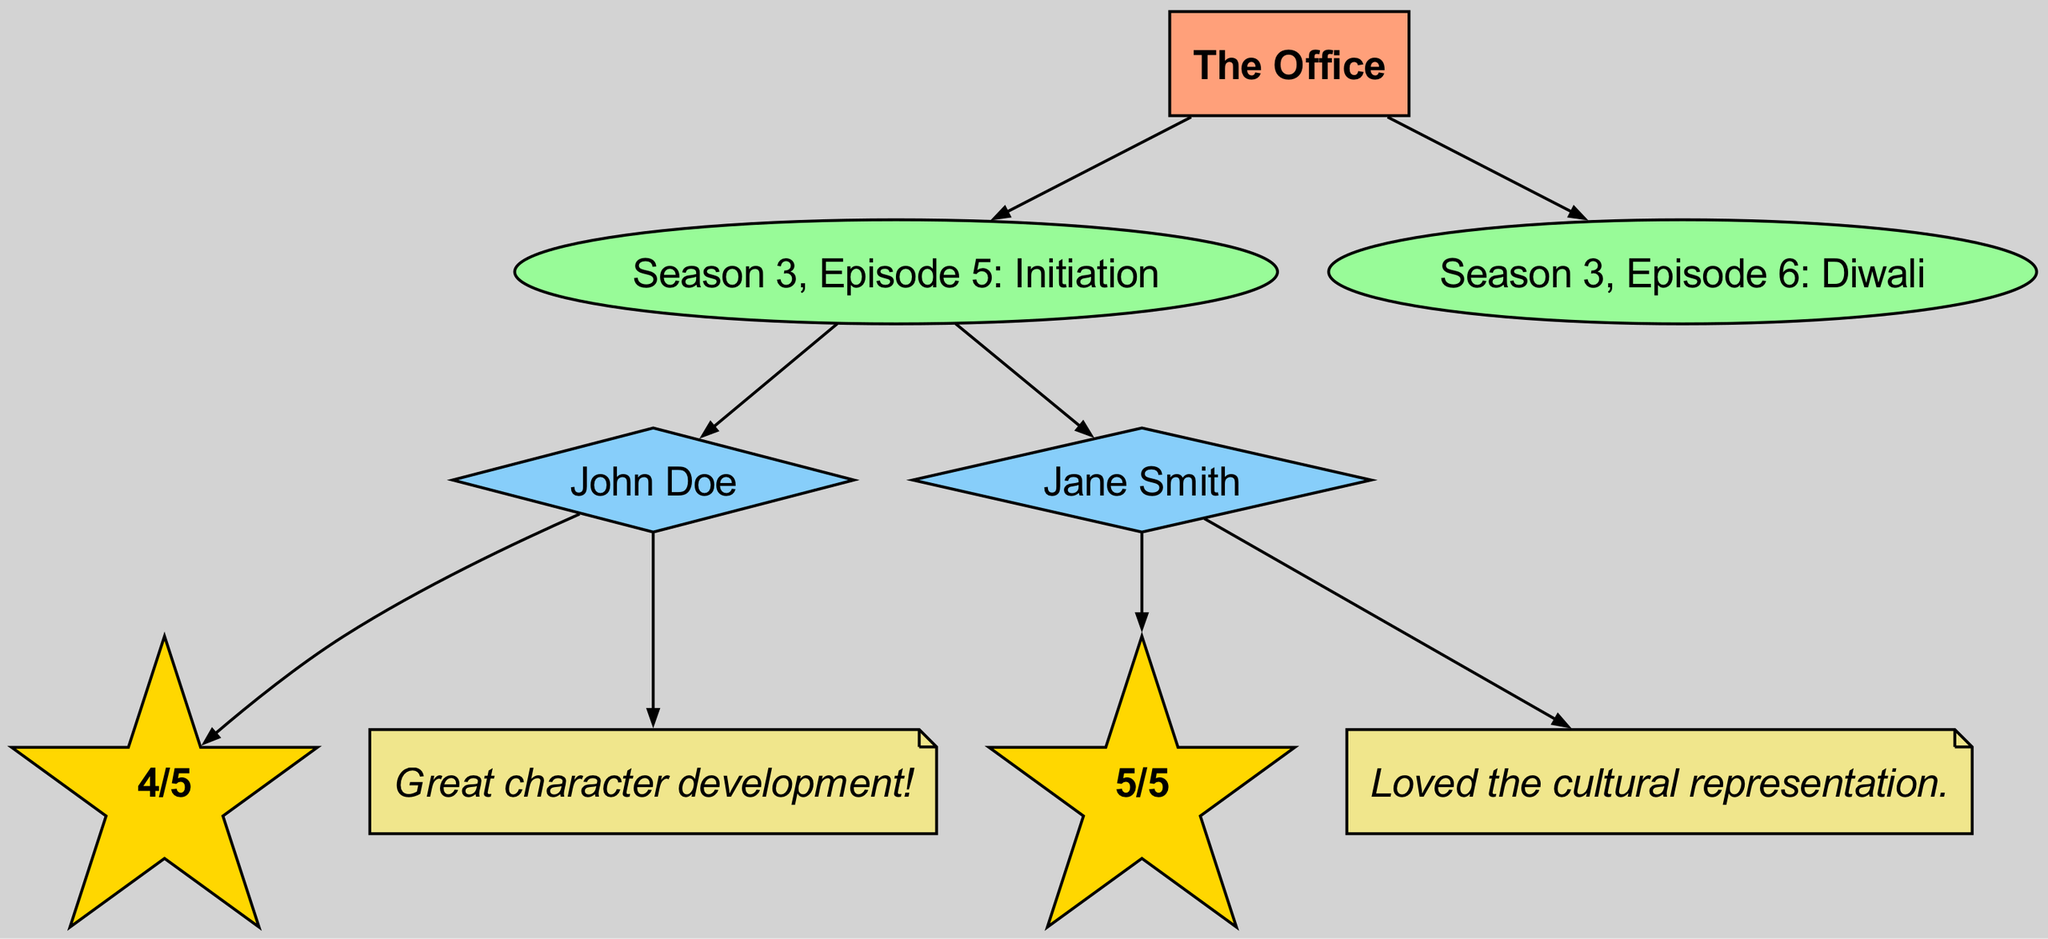What is the title of the series? The series node labeled "The Office" represents the title clearly.
Answer: The Office How many episodes are represented in the diagram? There are two episode nodes connected to the series node; they are “Season 3, Episode 5: Initiation” and “Season 3, Episode 6: Diwali.”
Answer: 2 Who is the reviewer for "Season 3, Episode 5: Initiation"? The directed edge from “Season 3, Episode 5: Initiation” leads to two reviewers: John Doe and Jane Smith, indicating their participation in reviewing this episode.
Answer: John Doe, Jane Smith Which rating did John Doe give to the episode? The edge from John Doe to the rating node shows that he rated it as "4/5". This is explicitly linked, demonstrating his rating for the episode.
Answer: 4/5 How many comments are there in total for the episodes? John Doe and Jane Smith have left one comment each, resulting in two comments overall, as each reviewer is connected to one comment node.
Answer: 2 Which episode received a higher rating and from whom? Comparing the ratings, "Season 3, Episode 5: Initiation" received "4/5" from John Doe, whereas "Season 3, Episode 6: Diwali" received "5/5" from Jane Smith, indicating that the latter episode had a higher rating.
Answer: Diwali, Jane Smith What shape represents reviewers in the diagram? Reviewers are represented by diamond-shaped nodes, which differentiates them visually from episodes and ratings based on the defined node styles in the diagram.
Answer: Diamond How many edges connect the series to its episodes? The series node "The Office" has two edges connected to its episodes, one for each episode node, showing the direct relationship from the series to the episodes.
Answer: 2 